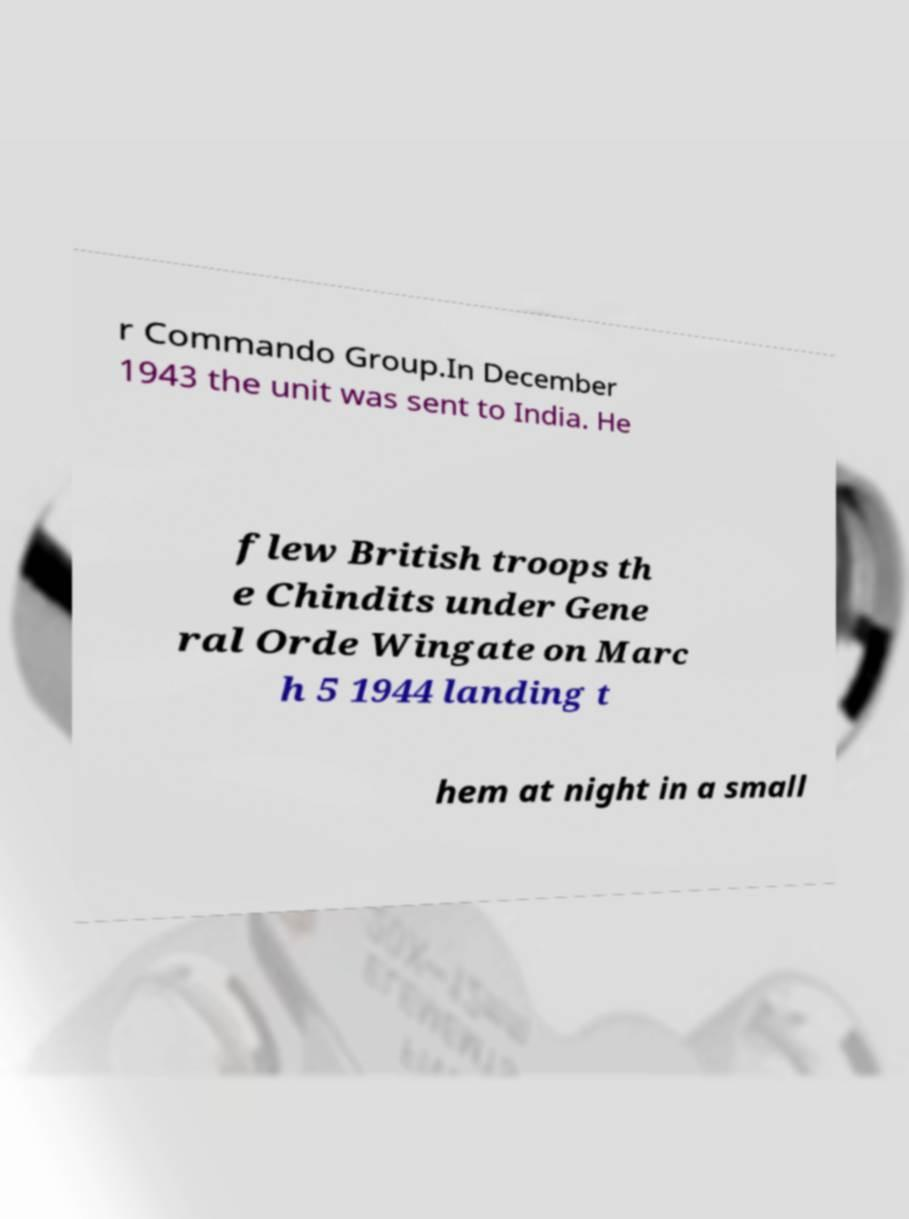Can you read and provide the text displayed in the image?This photo seems to have some interesting text. Can you extract and type it out for me? r Commando Group.In December 1943 the unit was sent to India. He flew British troops th e Chindits under Gene ral Orde Wingate on Marc h 5 1944 landing t hem at night in a small 